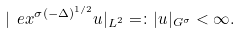Convert formula to latex. <formula><loc_0><loc_0><loc_500><loc_500>| \ e x ^ { \sigma ( - \Delta ) ^ { 1 / 2 } } u | _ { L ^ { 2 } } = \colon | u | _ { G ^ { \sigma } } < \infty .</formula> 